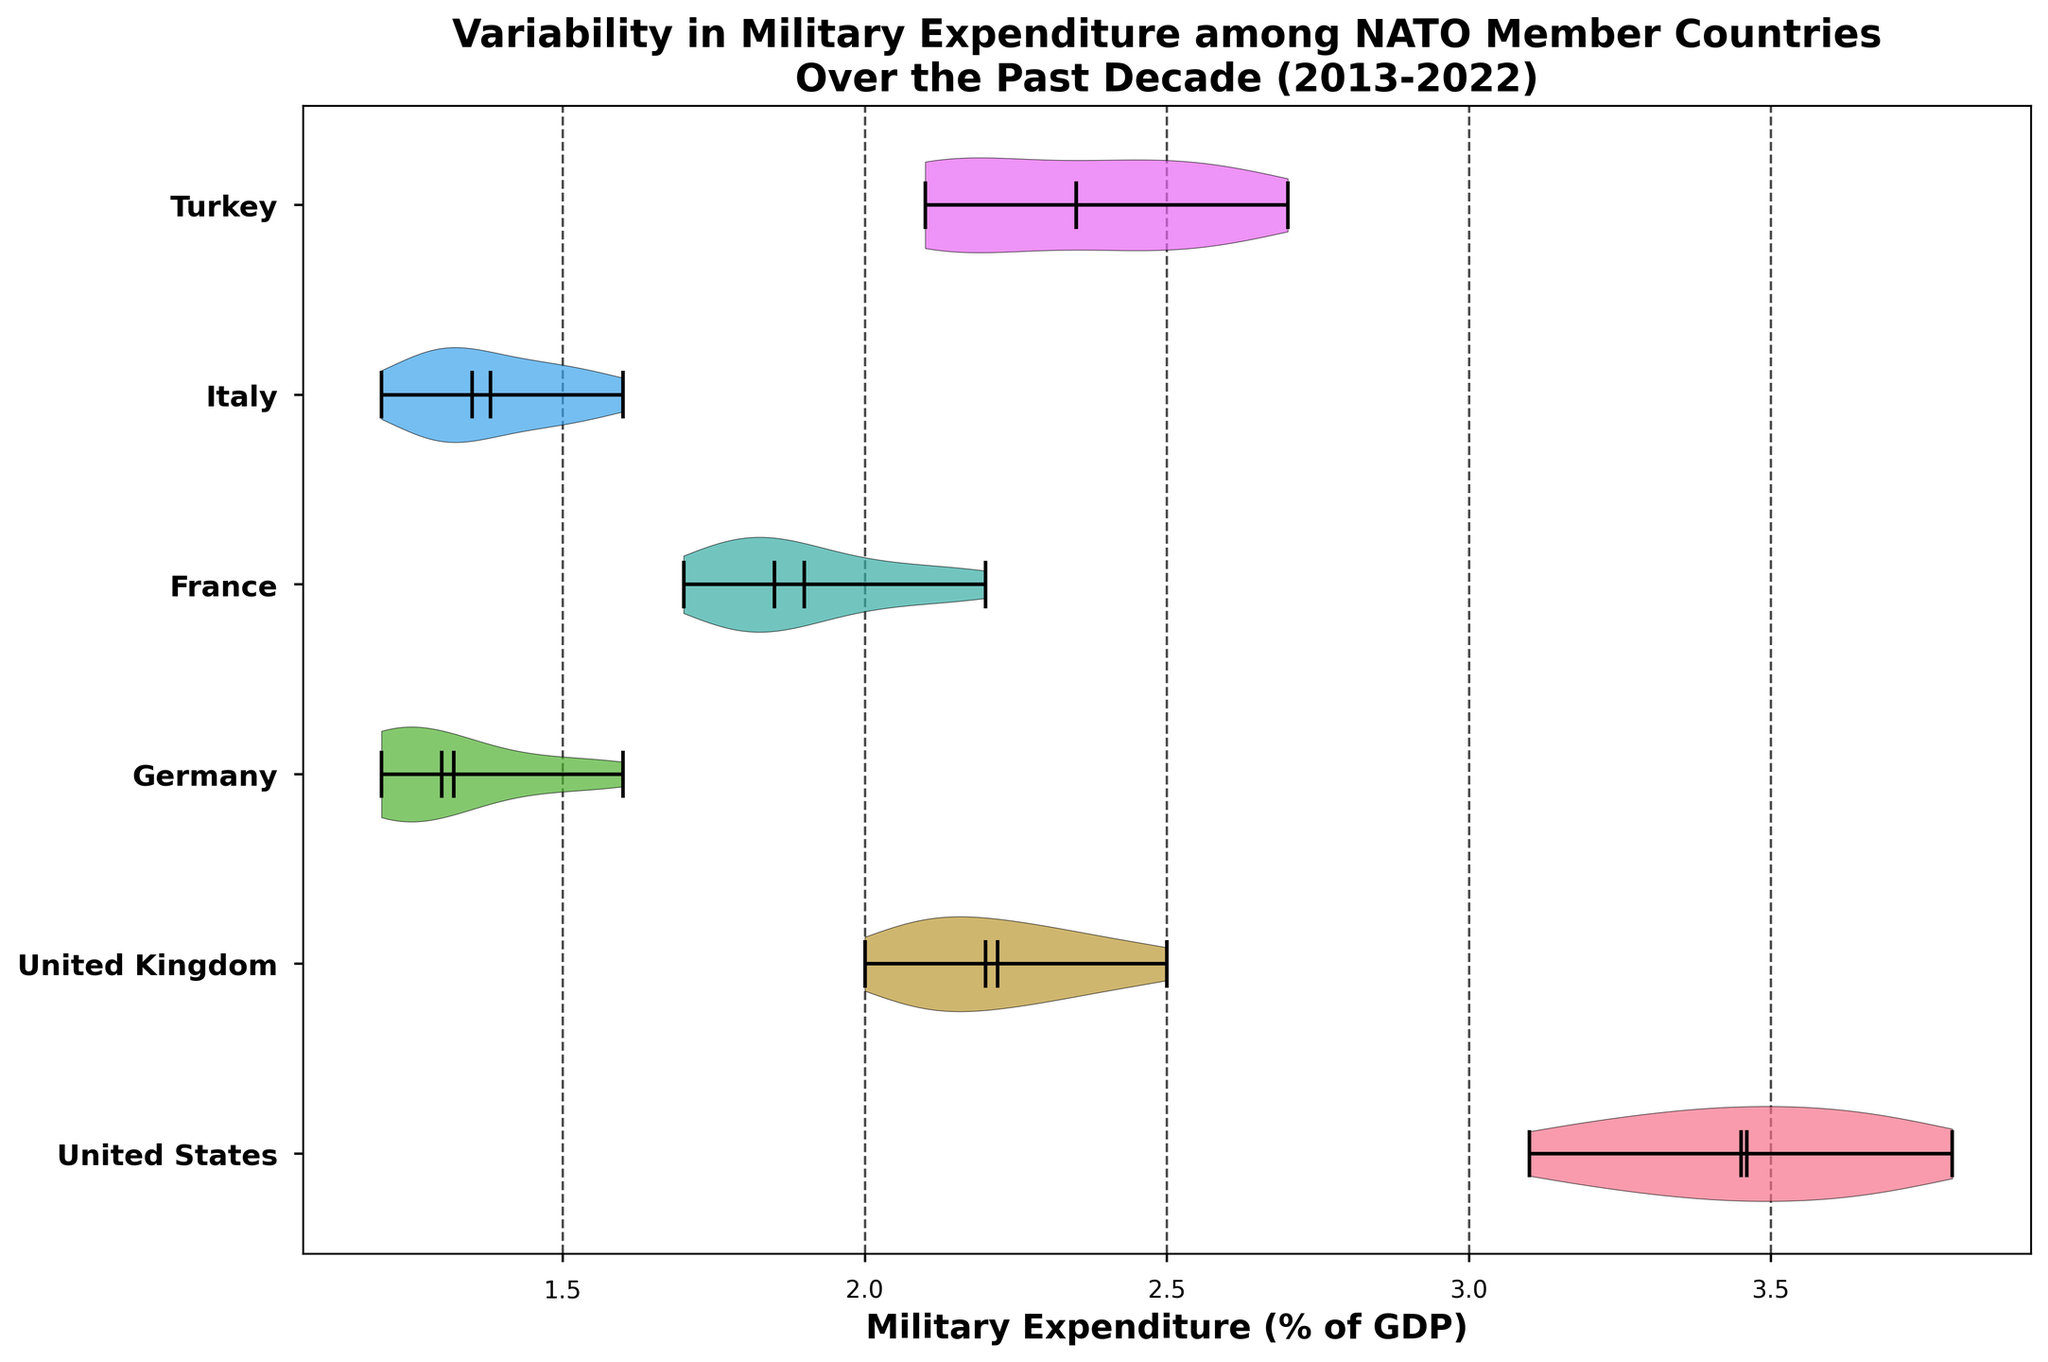What is the title of the chart? The title is typically found at the top of the chart. In this case, the title reads "Variability in Military Expenditure among NATO Member Countries Over the Past Decade (2013-2022)".
Answer: Variability in Military Expenditure among NATO Member Countries Over the Past Decade (2013-2022) Which country shows the highest median military expenditure as a percentage of GDP? To determine this, look at the horizontal line representing the median in each violin plot. The United States has the highest median line among all displayed countries.
Answer: United States What is the range of military expenditure for Germany? The range can be identified by looking at the endpoints of the violin plot for Germany. The minimum is 1.2% and the maximum is 1.6%.
Answer: 1.2% to 1.6% Which country has the largest variability in military expenditure as indicated by the width of the violin plot? Variability is shown by the spread or width of the violin plot. The United States has the widest violin plot, indicating the highest variability.
Answer: United States What is the mean military expenditure for Turkey? The mean is shown by a white dot within the violin plot. For Turkey, it appears to be close to 2.3%.
Answer: 2.3% Which country demonstrates an increasing trend in military expenditure over the past decade? To determine this, look at the positions of the data points within each violin plot. Both France and United Kingdom show a trend of increasing military expenditure over the years, but the United Kingdom has a more consistent increase.
Answer: United Kingdom Among the countries displayed, which one has the least median military expenditure? Compare the horizontal median lines of each violin plot. Germany has the lowest median line.
Answer: Germany Is Italy's military expenditure consistent over the past decade? Look at the shape of the violin plot for Italy. It's relatively narrow, indicating consistent expenditure.
Answer: Yes How does France's median military expenditure compare to Turkey's? Compare the horizontal median lines within the violin plots. France's median is lower than Turkey's median.
Answer: France's median is lower than Turkey's median 